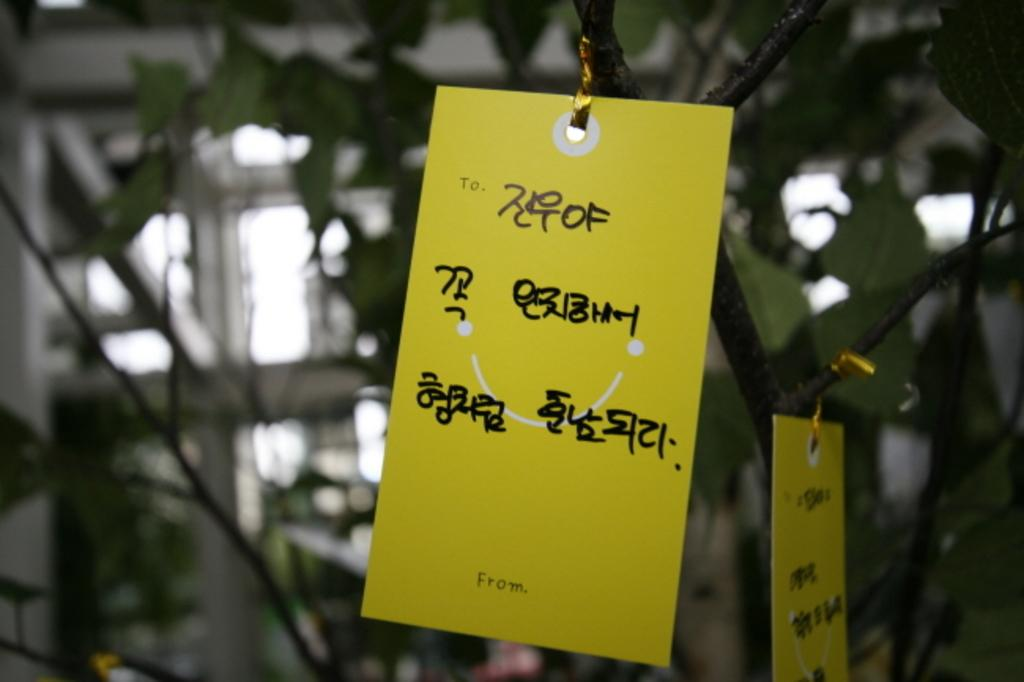What color is the paper that is visible in the image? The paper in the image is yellow. What can be seen in the background of the image? There is a tree in the background of the image. What type of account is being processed in the image? There is no account or process visible in the image; it only features a yellow paper and a tree in the background. 